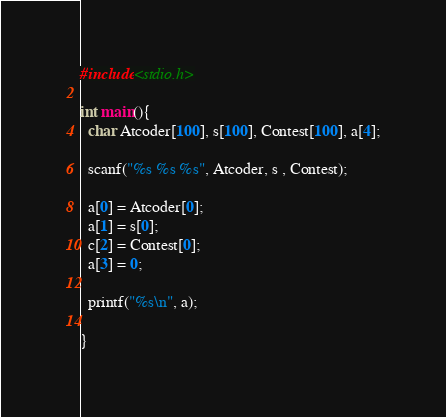<code> <loc_0><loc_0><loc_500><loc_500><_C_>#include<stdio.h>

int main(){
  char Atcoder[100], s[100], Contest[100], a[4];
  
  scanf("%s %s %s", Atcoder, s , Contest);
  
  a[0] = Atcoder[0];
  a[1] = s[0];
  c[2] = Contest[0];
  a[3] = 0;
  
  printf("%s\n", a);
  
}</code> 